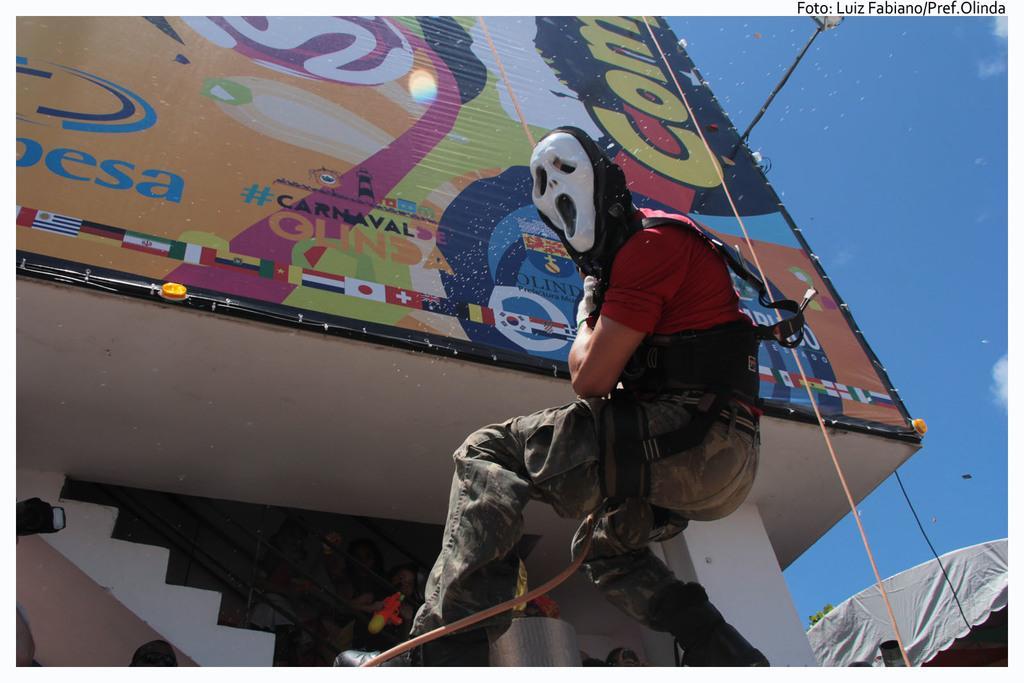How would you summarize this image in a sentence or two? In this image there is a person hanging, there is a rope, there is a board truncated, there are staircase, there is the sky, there is light truncated, there is an object truncated towards the right of the image. 